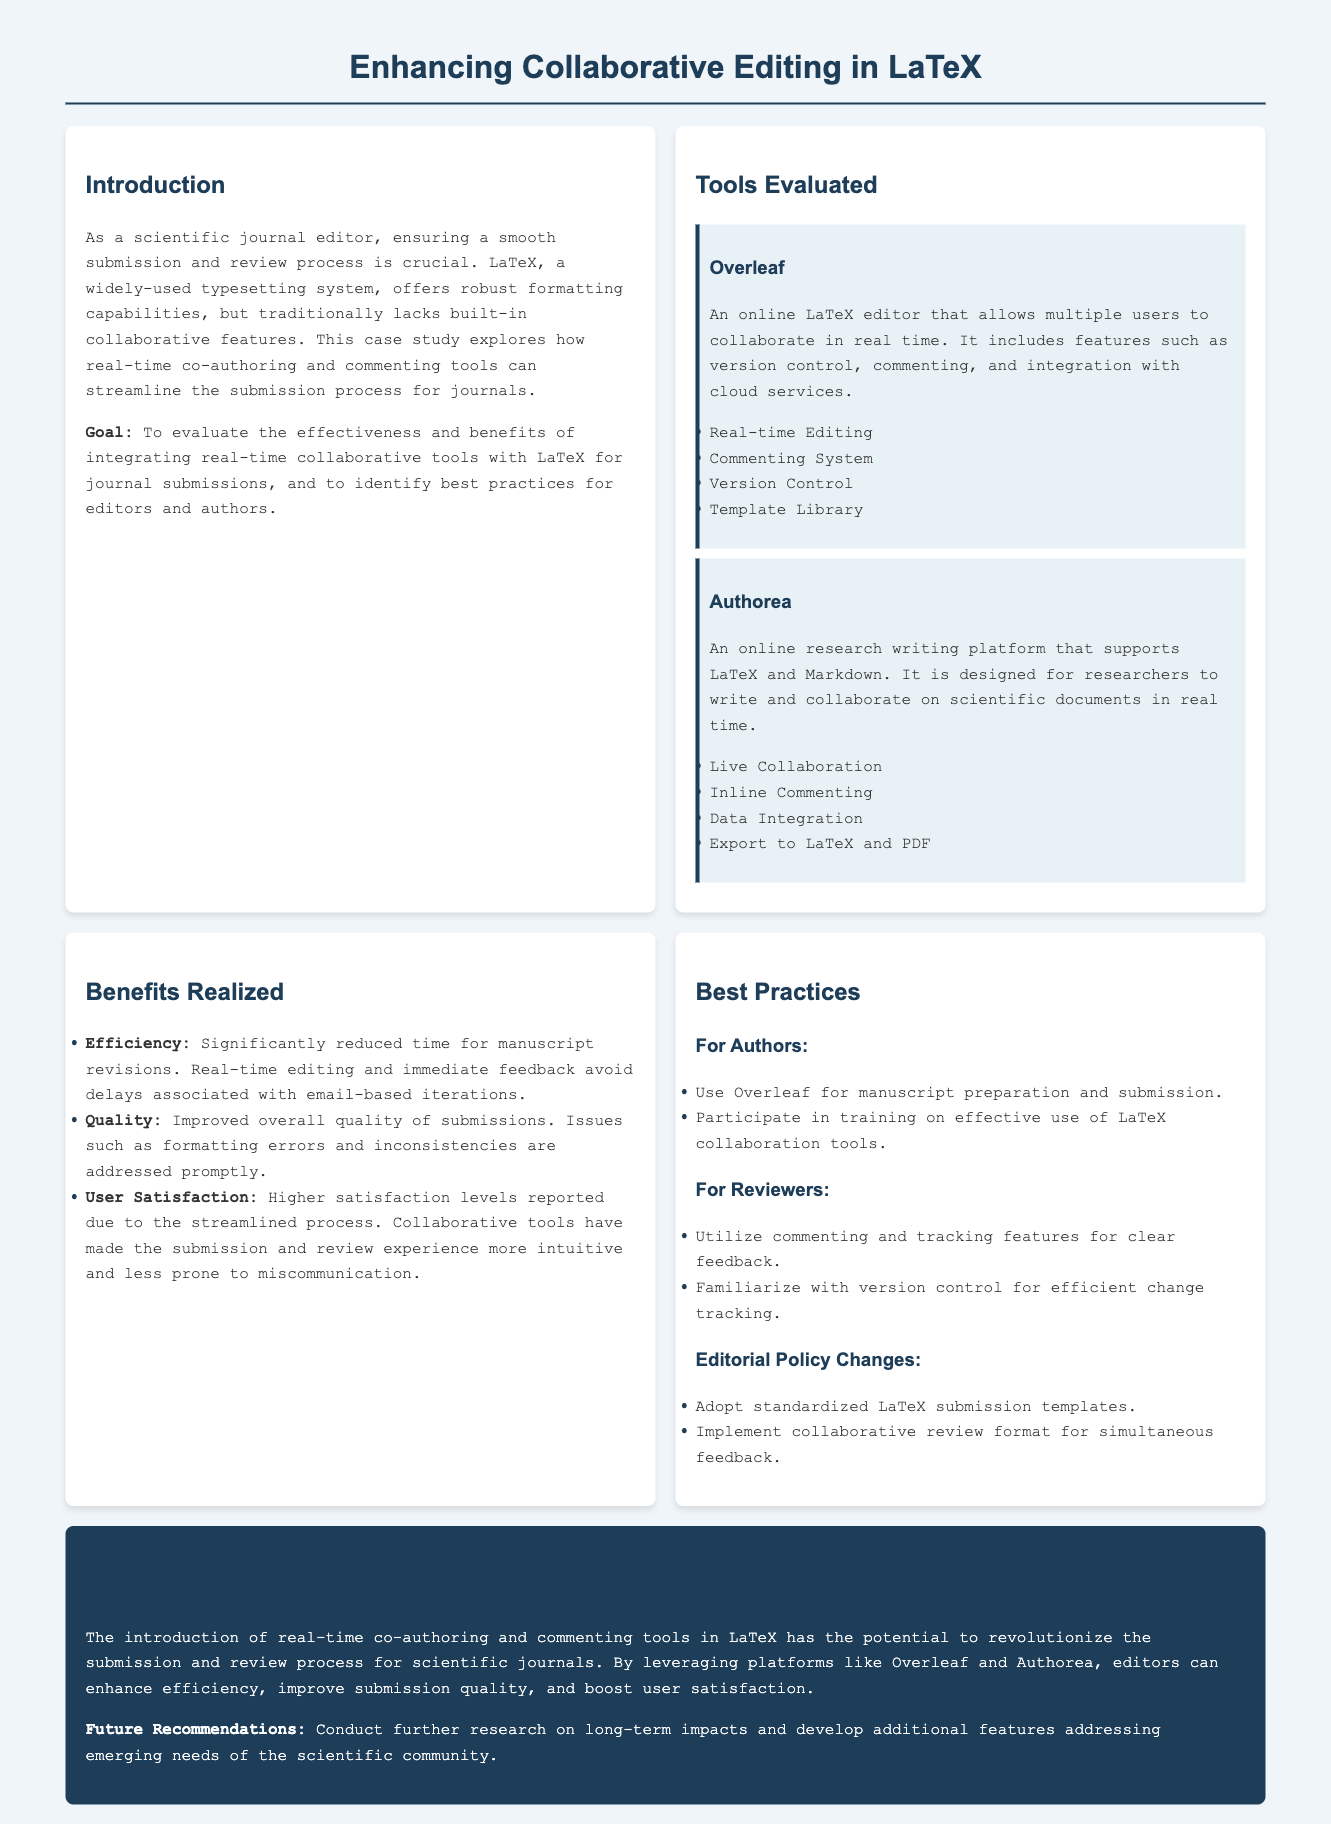What is the primary goal of the case study? The goal is to evaluate the effectiveness and benefits of integrating real-time collaborative tools with LaTeX for journal submissions, and to identify best practices for editors and authors.
Answer: To evaluate the effectiveness and benefits of integrating real-time collaborative tools with LaTeX for journal submissions What feature does Overleaf provide for collaboration? Overleaf provides a commenting system that allows users to leave feedback on the document in real time.
Answer: Commenting System Which tool is designed for researchers to write and collaborate using both LaTeX and Markdown? The tool designed for this purpose is Authorea, which supports live collaboration and inline commenting.
Answer: Authorea What is one of the benefits realized from implementing these collaborative tools? One benefit mentioned in the document is improved overall quality of submissions due to prompt addressing of formatting errors.
Answer: Improved overall quality of submissions What is a recommended practice for authors according to the document? Authors are advised to use Overleaf for manuscript preparation and submission, which facilitates collaboration.
Answer: Use Overleaf for manuscript preparation and submission How many tools were evaluated in the case study? Two tools, Overleaf and Authorea, were evaluated in the case study for their collaborative capabilities.
Answer: Two What editorial policy change is suggested in the case study? A suggested editorial policy change is to adopt standardized LaTeX submission templates to streamline the submission process.
Answer: Adopt standardized LaTeX submission templates What is the color of the conclusion section background? The conclusion section has a background color described as #1e3d59, which is a dark blue shade.
Answer: #1e3d59 What future recommendation is mentioned in the conclusion? The document recommends conducting further research on long-term impacts and developing additional features to meet the needs of the scientific community.
Answer: Conduct further research on long-term impacts 